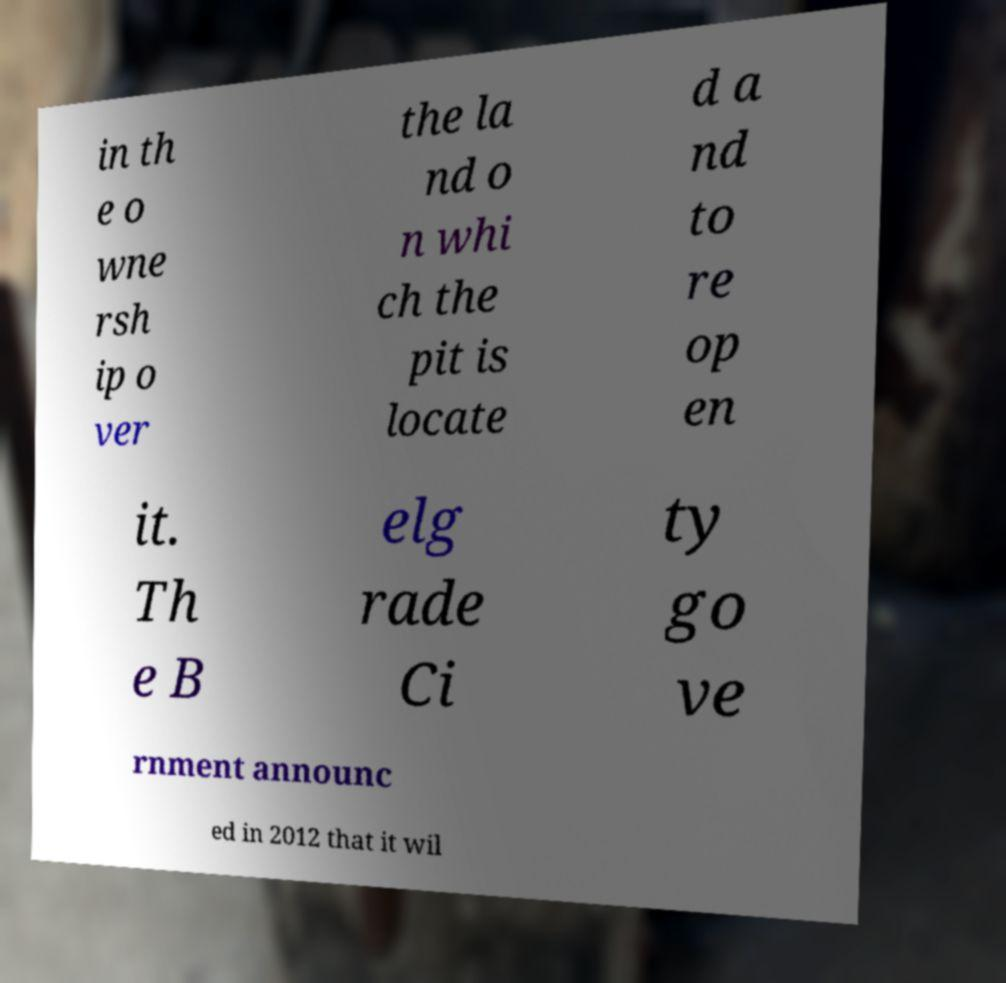Could you assist in decoding the text presented in this image and type it out clearly? in th e o wne rsh ip o ver the la nd o n whi ch the pit is locate d a nd to re op en it. Th e B elg rade Ci ty go ve rnment announc ed in 2012 that it wil 